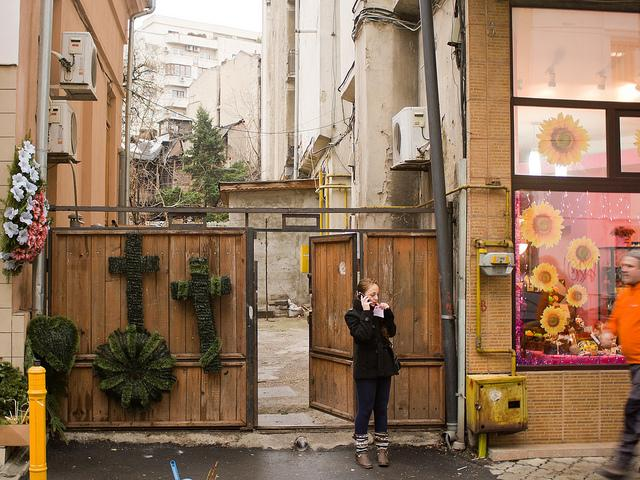What shape are two of the grass wreaths fashioned into? Please explain your reasoning. cross. They are shaped like a cross and hanging up. 